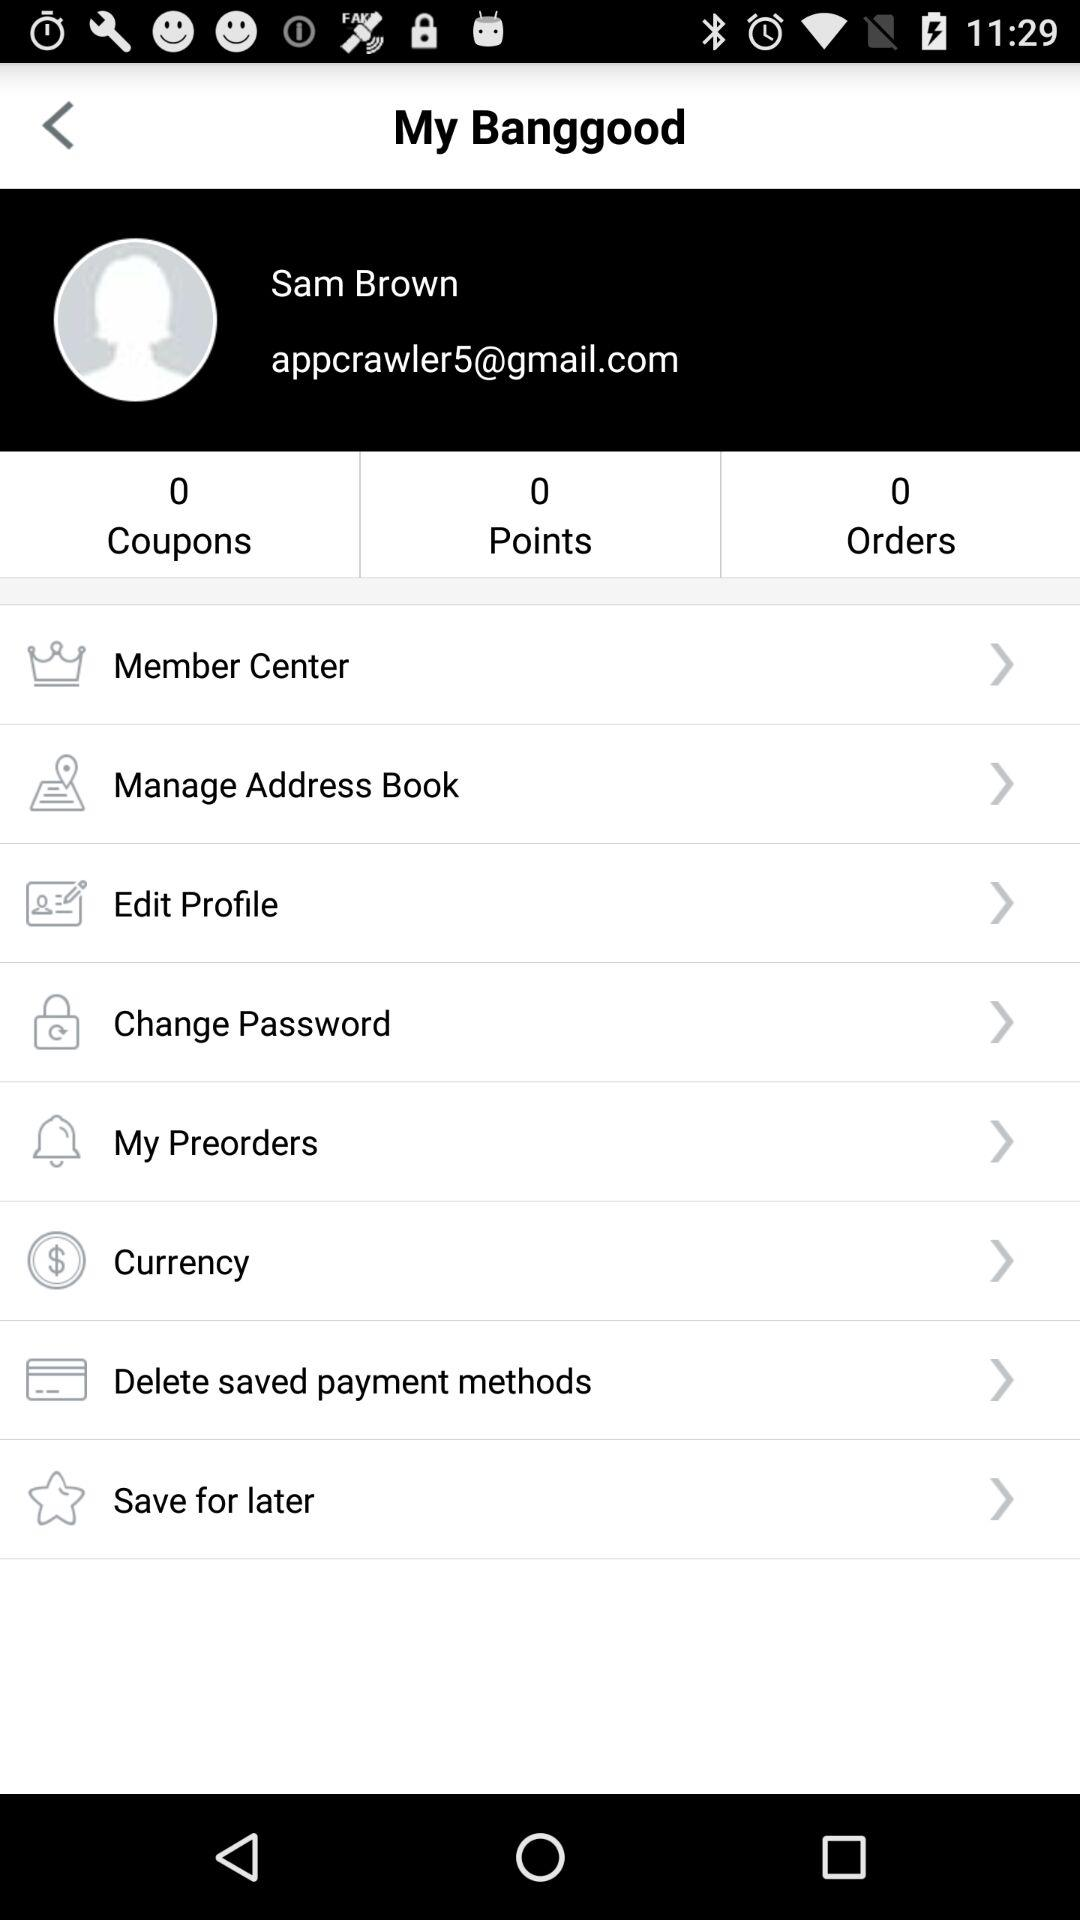How many points are shown? There are 0 points. 